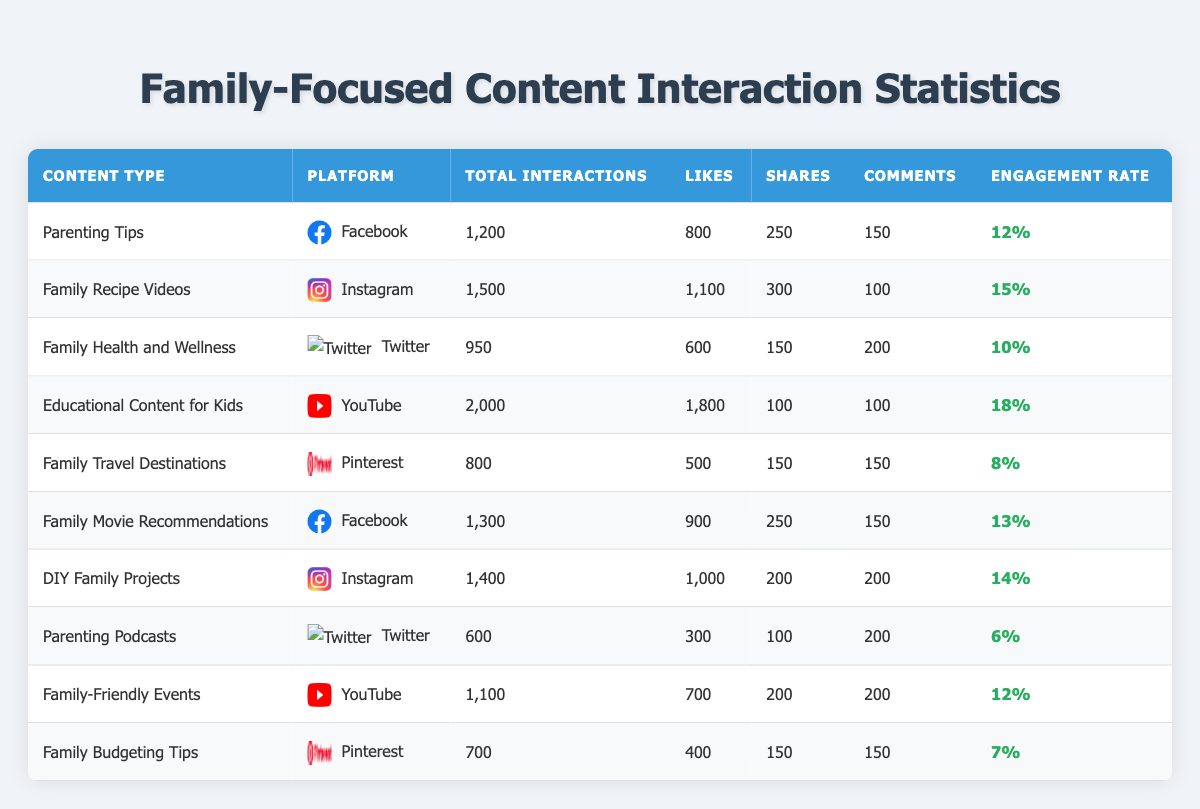What is the highest engagement rate among the listed content types? By inspecting the engagement rates listed for each content type, "Educational Content for Kids" has the highest at 18%.
Answer: 18% Which platform generated the most total interactions for family-focused content? Looking at the total interactions, "YouTube" with "Educational Content for Kids" has the highest total interactions at 2000.
Answer: YouTube How many likes did the "Family Recipe Videos" receive? The table shows that "Family Recipe Videos" received 1100 likes.
Answer: 1100 What is the total number of interactions for content types on Facebook? For Facebook, the total interactions are 1200 (Parenting Tips) + 1300 (Family Movie Recommendations) = 2500.
Answer: 2500 Is the engagement rate for "Family Travel Destinations" greater than that of "Family-Friendly Events"? "Family Travel Destinations" has an engagement rate of 8%, while "Family-Friendly Events" has 12%; therefore, 8% is not greater than 12%.
Answer: No Which content type on Twitter had the least total interactions? Comparing total interactions, "Parenting Podcasts" has the least with 600 total interactions on Twitter.
Answer: Parenting Podcasts How many total interactions did Instagram content types receive altogether? The total for Instagram is 1500 (Family Recipe Videos) + 1400 (DIY Family Projects) = 2900 interactions.
Answer: 2900 What percentage of interactions for "Family-Friendly Events" are comments? "Family-Friendly Events" has 200 comments out of 1100 Total Interactions, so (200/1100)*100 = 18.18%.
Answer: 18.18% If we consider content types with more than 1000 interactions, how many of those content types are available? The content types that exceed 1000 interactions are "Family Recipe Videos," "Educational Content for Kids," "Family Movie Recommendations," "DIY Family Projects," and "Family-Friendly Events," totaling 5.
Answer: 5 What is the difference in total interactions between the highest and lowest content types? The highest is "Educational Content for Kids" at 2000 interactions and the lowest is "Family Budgeting Tips" at 700 interactions, so the difference is 2000 - 700 = 1300.
Answer: 1300 